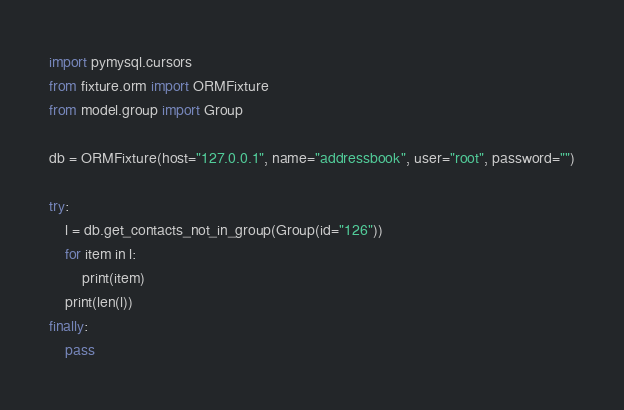Convert code to text. <code><loc_0><loc_0><loc_500><loc_500><_Python_>import pymysql.cursors
from fixture.orm import ORMFixture
from model.group import Group

db = ORMFixture(host="127.0.0.1", name="addressbook", user="root", password="")

try:
    l = db.get_contacts_not_in_group(Group(id="126"))
    for item in l:
        print(item)
    print(len(l))
finally:
    pass</code> 